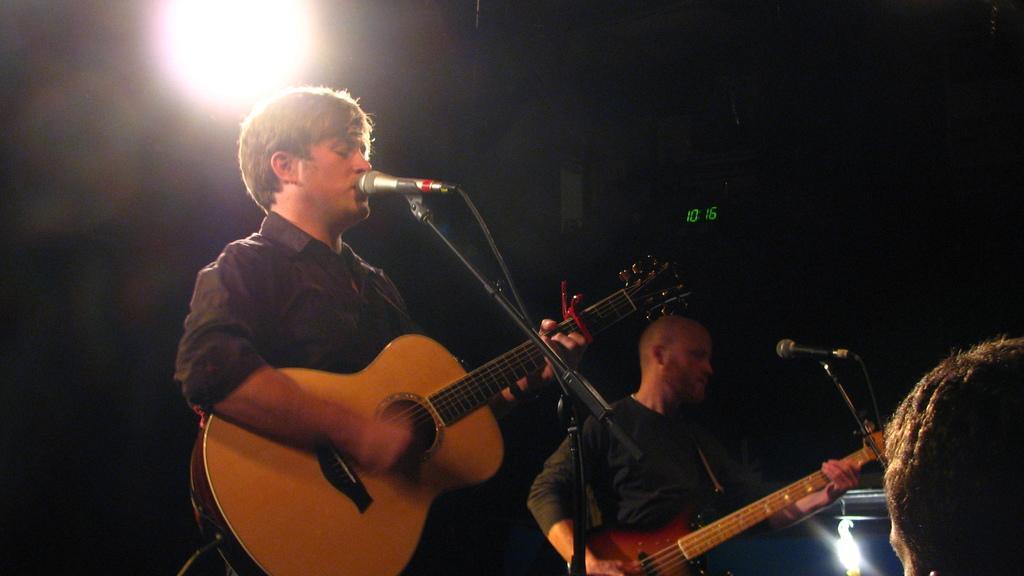Please provide a concise description of this image. In the image we can see there are people who are standing by holding guitar in their hand and there is mic in front of them with a stand. 